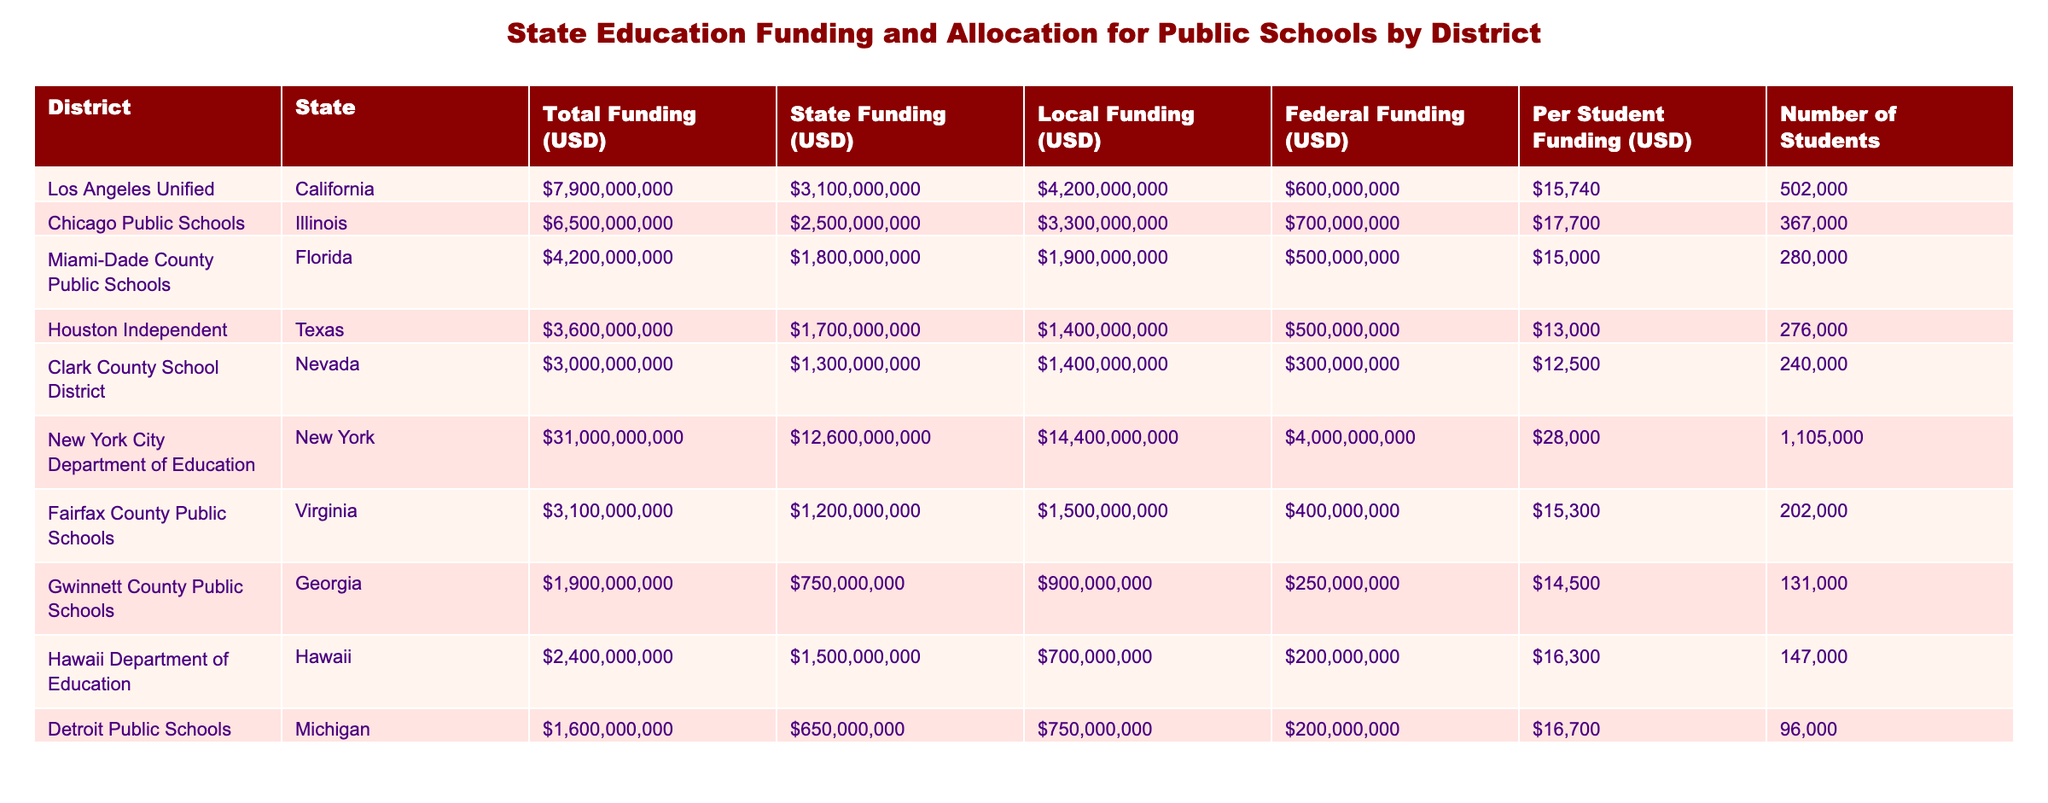What's the total funding for Chicago Public Schools? Looking at the "Total Funding (USD)" column for Chicago Public Schools, it shows a value of 6,500,000,000 USD.
Answer: 6,500,000,000 USD What is the per student funding for New York City Department of Education? By inspecting the "Per Student Funding (USD)" column for New York City Department of Education, the amount is 28,000 USD.
Answer: 28,000 USD Which district received the highest federal funding? Reviewing the "Federal Funding (USD)" column, New York City Department of Education has the highest federal funding at 4,000,000,000 USD compared to the other districts.
Answer: New York City Department of Education What is the total funding difference between Los Angeles Unified and Miami-Dade County Public Schools? The total funding for Los Angeles Unified is 7,900,000,000 USD, and for Miami-Dade, it is 4,200,000,000 USD. The difference is 7,900,000,000 - 4,200,000,000 = 3,700,000,000 USD.
Answer: 3,700,000,000 USD Is it true that Houston Independent School District has more local funding than Clark County School District? Comparing the "Local Funding (USD)" column, Houston Independent has 1,400,000,000 USD, while Clark County has 1,400,000,000 USD, making them equal. Therefore, the statement is false.
Answer: No What is the average per student funding across all districts? The total per student funding amounts are: 15,740, 17,700, 15,000, 13,000, 12,500, 28,000, 15,300, 14,500, 16,300, and 16,700. Summing these gives 16,300 and dividing by 10 (number of districts) results in an average of 16,300 USD.
Answer: 16,300 USD Which district has the most significant proportion of funding coming from local sources? To find the district with the highest local funding proportion, we calculate local funding as a percentage of total funding for each district. Miami-Dade (1900000000 / 4200000000) is approximately 45.24%, which is the highest percentage among the listed districts.
Answer: Miami-Dade County Public Schools How much more does Chicago Public Schools receive in state funding compared to Detroit Public Schools? Chicago Public Schools receive 2,500,000,000 USD in state funding, while Detroit Public Schools receive 650,000,000 USD. The difference is 2,500,000,000 - 650,000,000 = 1,850,000,000 USD.
Answer: 1,850,000,000 USD 